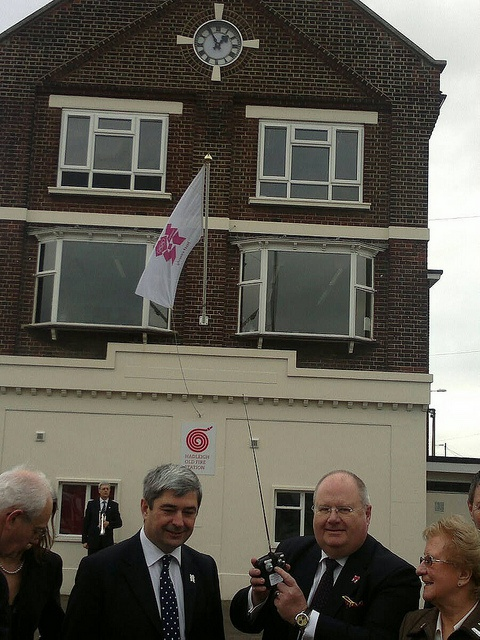Describe the objects in this image and their specific colors. I can see people in lightgray, black, maroon, and gray tones, people in lightgray, black, gray, maroon, and darkgray tones, people in lightgray, black, maroon, and gray tones, people in lightgray, black, maroon, and gray tones, and people in lightgray, black, gray, maroon, and darkgray tones in this image. 